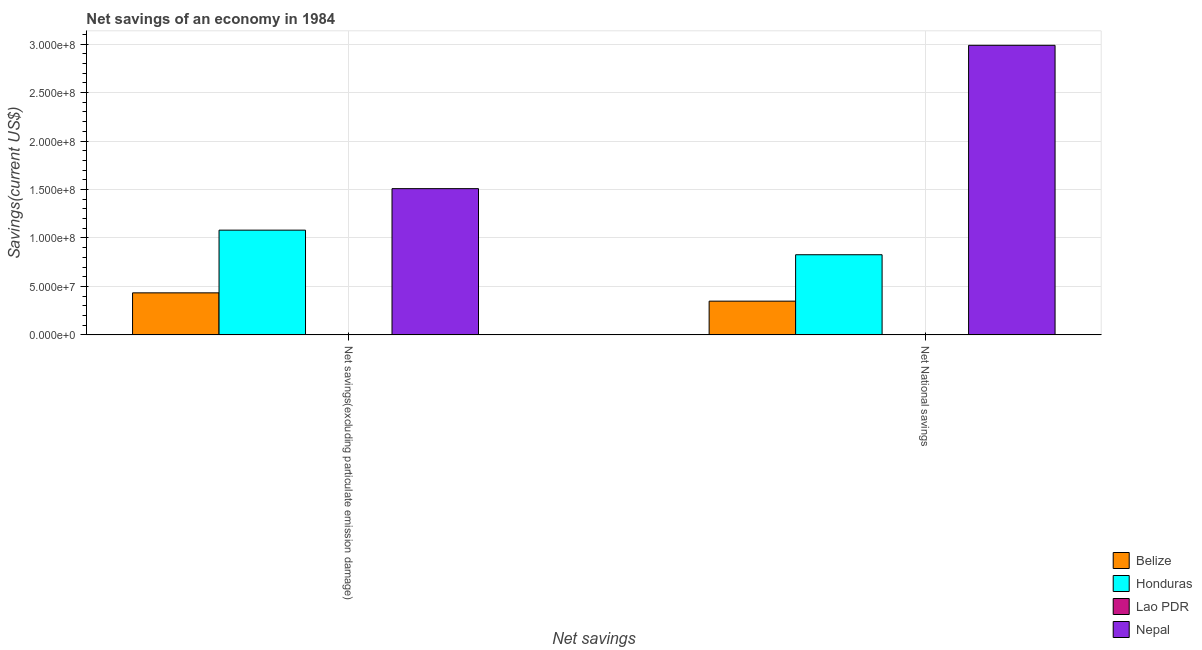Are the number of bars per tick equal to the number of legend labels?
Your answer should be compact. No. How many bars are there on the 2nd tick from the left?
Ensure brevity in your answer.  3. What is the label of the 2nd group of bars from the left?
Offer a very short reply. Net National savings. What is the net national savings in Honduras?
Offer a terse response. 8.27e+07. Across all countries, what is the maximum net national savings?
Your response must be concise. 2.99e+08. In which country was the net savings(excluding particulate emission damage) maximum?
Your answer should be very brief. Nepal. What is the total net national savings in the graph?
Ensure brevity in your answer.  4.16e+08. What is the difference between the net savings(excluding particulate emission damage) in Belize and that in Nepal?
Your response must be concise. -1.08e+08. What is the difference between the net savings(excluding particulate emission damage) in Honduras and the net national savings in Lao PDR?
Give a very brief answer. 1.08e+08. What is the average net savings(excluding particulate emission damage) per country?
Provide a succinct answer. 7.56e+07. What is the difference between the net national savings and net savings(excluding particulate emission damage) in Honduras?
Make the answer very short. -2.54e+07. In how many countries, is the net savings(excluding particulate emission damage) greater than 70000000 US$?
Offer a terse response. 2. What is the ratio of the net national savings in Honduras to that in Nepal?
Provide a succinct answer. 0.28. What is the difference between two consecutive major ticks on the Y-axis?
Your answer should be very brief. 5.00e+07. Does the graph contain any zero values?
Keep it short and to the point. Yes. Where does the legend appear in the graph?
Provide a succinct answer. Bottom right. How are the legend labels stacked?
Ensure brevity in your answer.  Vertical. What is the title of the graph?
Make the answer very short. Net savings of an economy in 1984. Does "Ukraine" appear as one of the legend labels in the graph?
Your answer should be very brief. No. What is the label or title of the X-axis?
Your response must be concise. Net savings. What is the label or title of the Y-axis?
Your answer should be very brief. Savings(current US$). What is the Savings(current US$) in Belize in Net savings(excluding particulate emission damage)?
Make the answer very short. 4.34e+07. What is the Savings(current US$) in Honduras in Net savings(excluding particulate emission damage)?
Give a very brief answer. 1.08e+08. What is the Savings(current US$) in Lao PDR in Net savings(excluding particulate emission damage)?
Your answer should be very brief. 0. What is the Savings(current US$) of Nepal in Net savings(excluding particulate emission damage)?
Offer a terse response. 1.51e+08. What is the Savings(current US$) in Belize in Net National savings?
Keep it short and to the point. 3.48e+07. What is the Savings(current US$) of Honduras in Net National savings?
Your response must be concise. 8.27e+07. What is the Savings(current US$) in Nepal in Net National savings?
Offer a very short reply. 2.99e+08. Across all Net savings, what is the maximum Savings(current US$) in Belize?
Your answer should be compact. 4.34e+07. Across all Net savings, what is the maximum Savings(current US$) in Honduras?
Make the answer very short. 1.08e+08. Across all Net savings, what is the maximum Savings(current US$) in Nepal?
Your answer should be compact. 2.99e+08. Across all Net savings, what is the minimum Savings(current US$) in Belize?
Provide a short and direct response. 3.48e+07. Across all Net savings, what is the minimum Savings(current US$) of Honduras?
Your answer should be very brief. 8.27e+07. Across all Net savings, what is the minimum Savings(current US$) in Nepal?
Offer a terse response. 1.51e+08. What is the total Savings(current US$) in Belize in the graph?
Give a very brief answer. 7.82e+07. What is the total Savings(current US$) in Honduras in the graph?
Provide a short and direct response. 1.91e+08. What is the total Savings(current US$) of Nepal in the graph?
Your answer should be compact. 4.50e+08. What is the difference between the Savings(current US$) in Belize in Net savings(excluding particulate emission damage) and that in Net National savings?
Your answer should be very brief. 8.56e+06. What is the difference between the Savings(current US$) in Honduras in Net savings(excluding particulate emission damage) and that in Net National savings?
Offer a very short reply. 2.54e+07. What is the difference between the Savings(current US$) of Nepal in Net savings(excluding particulate emission damage) and that in Net National savings?
Keep it short and to the point. -1.48e+08. What is the difference between the Savings(current US$) of Belize in Net savings(excluding particulate emission damage) and the Savings(current US$) of Honduras in Net National savings?
Your answer should be very brief. -3.93e+07. What is the difference between the Savings(current US$) of Belize in Net savings(excluding particulate emission damage) and the Savings(current US$) of Nepal in Net National savings?
Your response must be concise. -2.55e+08. What is the difference between the Savings(current US$) of Honduras in Net savings(excluding particulate emission damage) and the Savings(current US$) of Nepal in Net National savings?
Ensure brevity in your answer.  -1.91e+08. What is the average Savings(current US$) in Belize per Net savings?
Your answer should be very brief. 3.91e+07. What is the average Savings(current US$) in Honduras per Net savings?
Your answer should be compact. 9.54e+07. What is the average Savings(current US$) of Nepal per Net savings?
Your answer should be very brief. 2.25e+08. What is the difference between the Savings(current US$) of Belize and Savings(current US$) of Honduras in Net savings(excluding particulate emission damage)?
Offer a terse response. -6.47e+07. What is the difference between the Savings(current US$) of Belize and Savings(current US$) of Nepal in Net savings(excluding particulate emission damage)?
Give a very brief answer. -1.08e+08. What is the difference between the Savings(current US$) of Honduras and Savings(current US$) of Nepal in Net savings(excluding particulate emission damage)?
Keep it short and to the point. -4.28e+07. What is the difference between the Savings(current US$) in Belize and Savings(current US$) in Honduras in Net National savings?
Your response must be concise. -4.79e+07. What is the difference between the Savings(current US$) in Belize and Savings(current US$) in Nepal in Net National savings?
Ensure brevity in your answer.  -2.64e+08. What is the difference between the Savings(current US$) of Honduras and Savings(current US$) of Nepal in Net National savings?
Your answer should be very brief. -2.16e+08. What is the ratio of the Savings(current US$) in Belize in Net savings(excluding particulate emission damage) to that in Net National savings?
Your response must be concise. 1.25. What is the ratio of the Savings(current US$) of Honduras in Net savings(excluding particulate emission damage) to that in Net National savings?
Your response must be concise. 1.31. What is the ratio of the Savings(current US$) in Nepal in Net savings(excluding particulate emission damage) to that in Net National savings?
Ensure brevity in your answer.  0.51. What is the difference between the highest and the second highest Savings(current US$) of Belize?
Give a very brief answer. 8.56e+06. What is the difference between the highest and the second highest Savings(current US$) in Honduras?
Your answer should be very brief. 2.54e+07. What is the difference between the highest and the second highest Savings(current US$) of Nepal?
Provide a succinct answer. 1.48e+08. What is the difference between the highest and the lowest Savings(current US$) in Belize?
Offer a very short reply. 8.56e+06. What is the difference between the highest and the lowest Savings(current US$) in Honduras?
Your response must be concise. 2.54e+07. What is the difference between the highest and the lowest Savings(current US$) in Nepal?
Make the answer very short. 1.48e+08. 